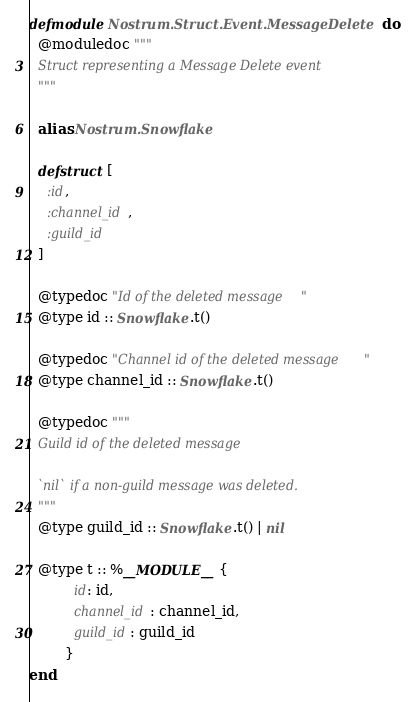Convert code to text. <code><loc_0><loc_0><loc_500><loc_500><_Elixir_>defmodule Nostrum.Struct.Event.MessageDelete do
  @moduledoc """
  Struct representing a Message Delete event
  """

  alias Nostrum.Snowflake

  defstruct [
    :id,
    :channel_id,
    :guild_id
  ]

  @typedoc "Id of the deleted message"
  @type id :: Snowflake.t()

  @typedoc "Channel id of the deleted message"
  @type channel_id :: Snowflake.t()

  @typedoc """
  Guild id of the deleted message

  `nil` if a non-guild message was deleted.
  """
  @type guild_id :: Snowflake.t() | nil

  @type t :: %__MODULE__{
          id: id,
          channel_id: channel_id,
          guild_id: guild_id
        }
end
</code> 